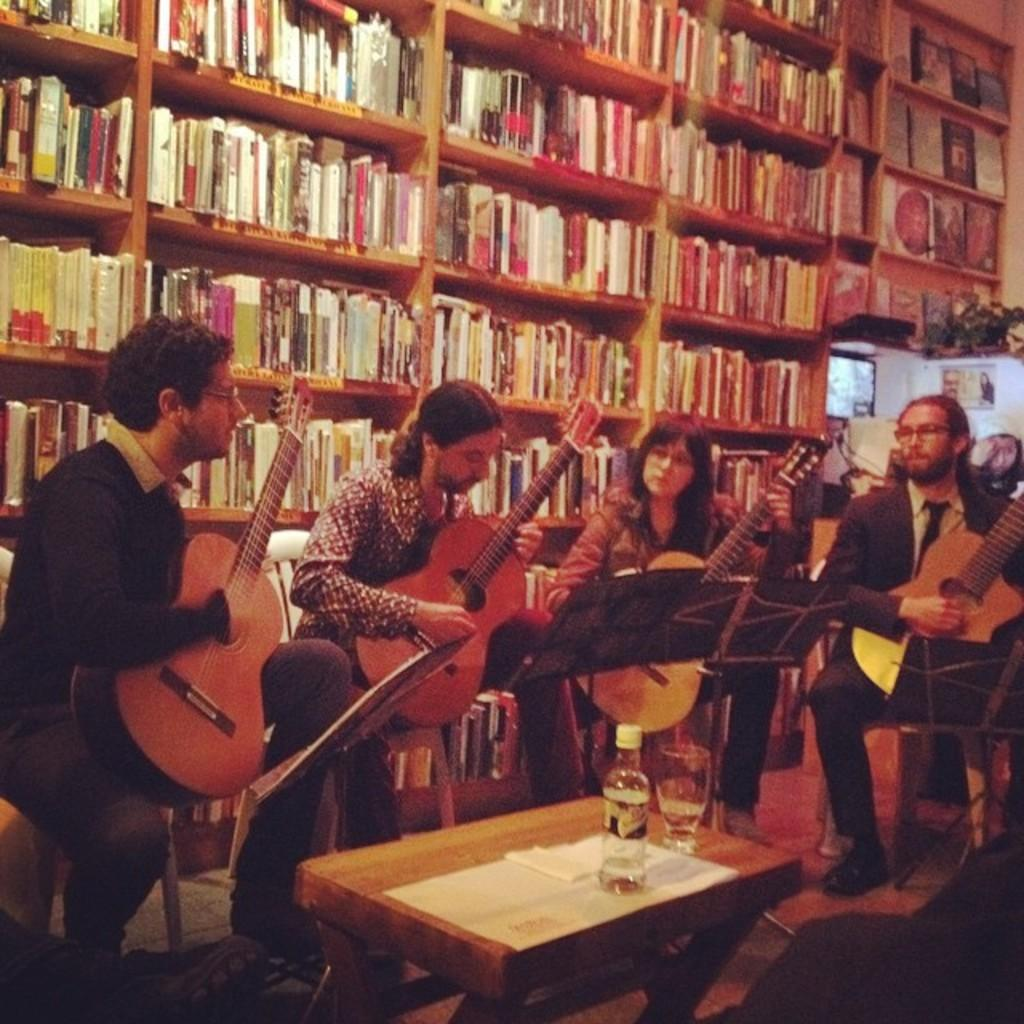What are the persons in the image doing? The persons in the image are playing guitar. What is present on the table in the image? There is a bottle and a glass on the table in the image. What can be seen in the background of the image? There is a rack and books in the background of the image. What type of leaf can be seen falling from the sky in the image? There are no leaves or clouds present in the image; it is an indoor scene with a guitar, table, bottle, glass, rack, and books. 